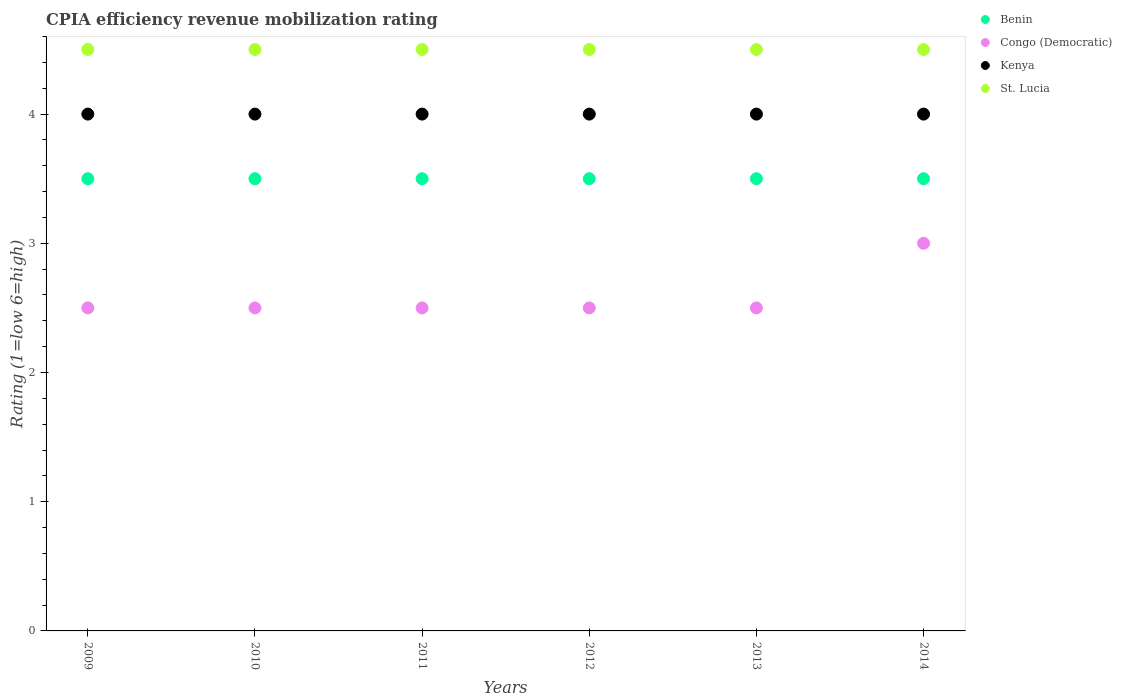Is the number of dotlines equal to the number of legend labels?
Give a very brief answer. Yes. What is the CPIA rating in Kenya in 2012?
Provide a short and direct response. 4. In which year was the CPIA rating in Benin minimum?
Ensure brevity in your answer.  2009. What is the total CPIA rating in Congo (Democratic) in the graph?
Keep it short and to the point. 15.5. What is the difference between the CPIA rating in Kenya in 2009 and the CPIA rating in Benin in 2010?
Offer a very short reply. 0.5. What is the ratio of the CPIA rating in Benin in 2010 to that in 2011?
Provide a succinct answer. 1. Is the CPIA rating in Kenya in 2009 less than that in 2012?
Offer a very short reply. No. What is the difference between the highest and the lowest CPIA rating in St. Lucia?
Provide a succinct answer. 0. Is the CPIA rating in Benin strictly greater than the CPIA rating in Congo (Democratic) over the years?
Keep it short and to the point. Yes. How many dotlines are there?
Keep it short and to the point. 4. How many years are there in the graph?
Offer a terse response. 6. What is the difference between two consecutive major ticks on the Y-axis?
Your answer should be compact. 1. Does the graph contain any zero values?
Your response must be concise. No. Does the graph contain grids?
Provide a short and direct response. No. Where does the legend appear in the graph?
Give a very brief answer. Top right. How many legend labels are there?
Ensure brevity in your answer.  4. What is the title of the graph?
Provide a short and direct response. CPIA efficiency revenue mobilization rating. Does "Tanzania" appear as one of the legend labels in the graph?
Offer a terse response. No. What is the label or title of the X-axis?
Give a very brief answer. Years. What is the Rating (1=low 6=high) in Benin in 2009?
Provide a succinct answer. 3.5. What is the Rating (1=low 6=high) in Congo (Democratic) in 2009?
Make the answer very short. 2.5. What is the Rating (1=low 6=high) of St. Lucia in 2010?
Keep it short and to the point. 4.5. What is the Rating (1=low 6=high) in Benin in 2011?
Provide a short and direct response. 3.5. What is the Rating (1=low 6=high) of St. Lucia in 2011?
Give a very brief answer. 4.5. What is the Rating (1=low 6=high) of Kenya in 2012?
Your response must be concise. 4. What is the Rating (1=low 6=high) in St. Lucia in 2012?
Provide a short and direct response. 4.5. What is the Rating (1=low 6=high) in Congo (Democratic) in 2013?
Keep it short and to the point. 2.5. What is the Rating (1=low 6=high) in Kenya in 2013?
Offer a terse response. 4. What is the Rating (1=low 6=high) in St. Lucia in 2013?
Your answer should be very brief. 4.5. What is the Rating (1=low 6=high) in Congo (Democratic) in 2014?
Provide a short and direct response. 3. What is the Rating (1=low 6=high) in Kenya in 2014?
Give a very brief answer. 4. Across all years, what is the maximum Rating (1=low 6=high) in St. Lucia?
Your answer should be very brief. 4.5. What is the total Rating (1=low 6=high) of Congo (Democratic) in the graph?
Keep it short and to the point. 15.5. What is the total Rating (1=low 6=high) in Kenya in the graph?
Make the answer very short. 24. What is the total Rating (1=low 6=high) in St. Lucia in the graph?
Ensure brevity in your answer.  27. What is the difference between the Rating (1=low 6=high) in Benin in 2009 and that in 2010?
Offer a very short reply. 0. What is the difference between the Rating (1=low 6=high) in Kenya in 2009 and that in 2010?
Keep it short and to the point. 0. What is the difference between the Rating (1=low 6=high) in Benin in 2009 and that in 2011?
Provide a succinct answer. 0. What is the difference between the Rating (1=low 6=high) of Congo (Democratic) in 2009 and that in 2011?
Offer a very short reply. 0. What is the difference between the Rating (1=low 6=high) in Benin in 2009 and that in 2012?
Make the answer very short. 0. What is the difference between the Rating (1=low 6=high) of Kenya in 2009 and that in 2012?
Your response must be concise. 0. What is the difference between the Rating (1=low 6=high) of St. Lucia in 2009 and that in 2012?
Give a very brief answer. 0. What is the difference between the Rating (1=low 6=high) of Kenya in 2009 and that in 2013?
Your answer should be very brief. 0. What is the difference between the Rating (1=low 6=high) of St. Lucia in 2009 and that in 2013?
Ensure brevity in your answer.  0. What is the difference between the Rating (1=low 6=high) in Benin in 2009 and that in 2014?
Give a very brief answer. 0. What is the difference between the Rating (1=low 6=high) in Congo (Democratic) in 2009 and that in 2014?
Provide a short and direct response. -0.5. What is the difference between the Rating (1=low 6=high) in Kenya in 2009 and that in 2014?
Ensure brevity in your answer.  0. What is the difference between the Rating (1=low 6=high) of Benin in 2010 and that in 2011?
Offer a very short reply. 0. What is the difference between the Rating (1=low 6=high) in St. Lucia in 2010 and that in 2011?
Keep it short and to the point. 0. What is the difference between the Rating (1=low 6=high) of Congo (Democratic) in 2010 and that in 2013?
Make the answer very short. 0. What is the difference between the Rating (1=low 6=high) in Congo (Democratic) in 2010 and that in 2014?
Give a very brief answer. -0.5. What is the difference between the Rating (1=low 6=high) of St. Lucia in 2010 and that in 2014?
Your answer should be compact. 0. What is the difference between the Rating (1=low 6=high) of Congo (Democratic) in 2011 and that in 2012?
Provide a short and direct response. 0. What is the difference between the Rating (1=low 6=high) of St. Lucia in 2011 and that in 2012?
Offer a terse response. 0. What is the difference between the Rating (1=low 6=high) of Congo (Democratic) in 2011 and that in 2013?
Provide a short and direct response. 0. What is the difference between the Rating (1=low 6=high) in Congo (Democratic) in 2011 and that in 2014?
Provide a succinct answer. -0.5. What is the difference between the Rating (1=low 6=high) in St. Lucia in 2011 and that in 2014?
Offer a terse response. 0. What is the difference between the Rating (1=low 6=high) in Congo (Democratic) in 2012 and that in 2013?
Ensure brevity in your answer.  0. What is the difference between the Rating (1=low 6=high) of Kenya in 2012 and that in 2013?
Provide a short and direct response. 0. What is the difference between the Rating (1=low 6=high) of St. Lucia in 2012 and that in 2013?
Offer a very short reply. 0. What is the difference between the Rating (1=low 6=high) of Benin in 2012 and that in 2014?
Offer a terse response. 0. What is the difference between the Rating (1=low 6=high) in Congo (Democratic) in 2012 and that in 2014?
Your answer should be compact. -0.5. What is the difference between the Rating (1=low 6=high) in St. Lucia in 2012 and that in 2014?
Provide a succinct answer. 0. What is the difference between the Rating (1=low 6=high) of Benin in 2013 and that in 2014?
Your response must be concise. 0. What is the difference between the Rating (1=low 6=high) of Congo (Democratic) in 2013 and that in 2014?
Keep it short and to the point. -0.5. What is the difference between the Rating (1=low 6=high) in St. Lucia in 2013 and that in 2014?
Offer a terse response. 0. What is the difference between the Rating (1=low 6=high) in Benin in 2009 and the Rating (1=low 6=high) in Congo (Democratic) in 2010?
Keep it short and to the point. 1. What is the difference between the Rating (1=low 6=high) in Congo (Democratic) in 2009 and the Rating (1=low 6=high) in Kenya in 2010?
Offer a very short reply. -1.5. What is the difference between the Rating (1=low 6=high) of Congo (Democratic) in 2009 and the Rating (1=low 6=high) of St. Lucia in 2010?
Give a very brief answer. -2. What is the difference between the Rating (1=low 6=high) in Congo (Democratic) in 2009 and the Rating (1=low 6=high) in Kenya in 2011?
Your answer should be very brief. -1.5. What is the difference between the Rating (1=low 6=high) of Congo (Democratic) in 2009 and the Rating (1=low 6=high) of St. Lucia in 2011?
Offer a very short reply. -2. What is the difference between the Rating (1=low 6=high) in Benin in 2009 and the Rating (1=low 6=high) in Congo (Democratic) in 2012?
Make the answer very short. 1. What is the difference between the Rating (1=low 6=high) in Benin in 2009 and the Rating (1=low 6=high) in St. Lucia in 2012?
Give a very brief answer. -1. What is the difference between the Rating (1=low 6=high) in Kenya in 2009 and the Rating (1=low 6=high) in St. Lucia in 2012?
Your answer should be compact. -0.5. What is the difference between the Rating (1=low 6=high) of Benin in 2009 and the Rating (1=low 6=high) of Congo (Democratic) in 2013?
Your response must be concise. 1. What is the difference between the Rating (1=low 6=high) in Benin in 2009 and the Rating (1=low 6=high) in Kenya in 2013?
Ensure brevity in your answer.  -0.5. What is the difference between the Rating (1=low 6=high) in Congo (Democratic) in 2009 and the Rating (1=low 6=high) in Kenya in 2013?
Keep it short and to the point. -1.5. What is the difference between the Rating (1=low 6=high) in Benin in 2009 and the Rating (1=low 6=high) in St. Lucia in 2014?
Your response must be concise. -1. What is the difference between the Rating (1=low 6=high) in Congo (Democratic) in 2009 and the Rating (1=low 6=high) in Kenya in 2014?
Your answer should be compact. -1.5. What is the difference between the Rating (1=low 6=high) in Congo (Democratic) in 2009 and the Rating (1=low 6=high) in St. Lucia in 2014?
Keep it short and to the point. -2. What is the difference between the Rating (1=low 6=high) in Kenya in 2009 and the Rating (1=low 6=high) in St. Lucia in 2014?
Your response must be concise. -0.5. What is the difference between the Rating (1=low 6=high) in Benin in 2010 and the Rating (1=low 6=high) in Congo (Democratic) in 2011?
Give a very brief answer. 1. What is the difference between the Rating (1=low 6=high) in Benin in 2010 and the Rating (1=low 6=high) in St. Lucia in 2011?
Offer a terse response. -1. What is the difference between the Rating (1=low 6=high) in Congo (Democratic) in 2010 and the Rating (1=low 6=high) in St. Lucia in 2011?
Provide a short and direct response. -2. What is the difference between the Rating (1=low 6=high) in Kenya in 2010 and the Rating (1=low 6=high) in St. Lucia in 2011?
Your answer should be very brief. -0.5. What is the difference between the Rating (1=low 6=high) of Benin in 2010 and the Rating (1=low 6=high) of Congo (Democratic) in 2012?
Provide a succinct answer. 1. What is the difference between the Rating (1=low 6=high) of Benin in 2010 and the Rating (1=low 6=high) of Kenya in 2012?
Your answer should be compact. -0.5. What is the difference between the Rating (1=low 6=high) in Congo (Democratic) in 2010 and the Rating (1=low 6=high) in Kenya in 2012?
Make the answer very short. -1.5. What is the difference between the Rating (1=low 6=high) in Benin in 2010 and the Rating (1=low 6=high) in St. Lucia in 2013?
Keep it short and to the point. -1. What is the difference between the Rating (1=low 6=high) of Congo (Democratic) in 2010 and the Rating (1=low 6=high) of Kenya in 2013?
Your answer should be very brief. -1.5. What is the difference between the Rating (1=low 6=high) in Congo (Democratic) in 2010 and the Rating (1=low 6=high) in St. Lucia in 2013?
Offer a very short reply. -2. What is the difference between the Rating (1=low 6=high) of Benin in 2010 and the Rating (1=low 6=high) of Congo (Democratic) in 2014?
Offer a terse response. 0.5. What is the difference between the Rating (1=low 6=high) in Congo (Democratic) in 2010 and the Rating (1=low 6=high) in Kenya in 2014?
Give a very brief answer. -1.5. What is the difference between the Rating (1=low 6=high) in Congo (Democratic) in 2010 and the Rating (1=low 6=high) in St. Lucia in 2014?
Your answer should be very brief. -2. What is the difference between the Rating (1=low 6=high) in Benin in 2011 and the Rating (1=low 6=high) in St. Lucia in 2012?
Your response must be concise. -1. What is the difference between the Rating (1=low 6=high) in Kenya in 2011 and the Rating (1=low 6=high) in St. Lucia in 2012?
Offer a terse response. -0.5. What is the difference between the Rating (1=low 6=high) in Congo (Democratic) in 2011 and the Rating (1=low 6=high) in Kenya in 2013?
Keep it short and to the point. -1.5. What is the difference between the Rating (1=low 6=high) in Benin in 2011 and the Rating (1=low 6=high) in Congo (Democratic) in 2014?
Your response must be concise. 0.5. What is the difference between the Rating (1=low 6=high) in Benin in 2011 and the Rating (1=low 6=high) in St. Lucia in 2014?
Make the answer very short. -1. What is the difference between the Rating (1=low 6=high) of Congo (Democratic) in 2011 and the Rating (1=low 6=high) of Kenya in 2014?
Your answer should be compact. -1.5. What is the difference between the Rating (1=low 6=high) of Benin in 2012 and the Rating (1=low 6=high) of Kenya in 2013?
Provide a short and direct response. -0.5. What is the difference between the Rating (1=low 6=high) in Benin in 2012 and the Rating (1=low 6=high) in St. Lucia in 2013?
Keep it short and to the point. -1. What is the difference between the Rating (1=low 6=high) in Congo (Democratic) in 2012 and the Rating (1=low 6=high) in St. Lucia in 2013?
Provide a short and direct response. -2. What is the difference between the Rating (1=low 6=high) of Kenya in 2012 and the Rating (1=low 6=high) of St. Lucia in 2013?
Your response must be concise. -0.5. What is the difference between the Rating (1=low 6=high) of Benin in 2012 and the Rating (1=low 6=high) of Congo (Democratic) in 2014?
Provide a short and direct response. 0.5. What is the difference between the Rating (1=low 6=high) of Benin in 2012 and the Rating (1=low 6=high) of Kenya in 2014?
Make the answer very short. -0.5. What is the difference between the Rating (1=low 6=high) in Benin in 2012 and the Rating (1=low 6=high) in St. Lucia in 2014?
Offer a terse response. -1. What is the difference between the Rating (1=low 6=high) of Congo (Democratic) in 2012 and the Rating (1=low 6=high) of Kenya in 2014?
Provide a short and direct response. -1.5. What is the difference between the Rating (1=low 6=high) in Benin in 2013 and the Rating (1=low 6=high) in Kenya in 2014?
Keep it short and to the point. -0.5. What is the difference between the Rating (1=low 6=high) of Congo (Democratic) in 2013 and the Rating (1=low 6=high) of Kenya in 2014?
Offer a very short reply. -1.5. What is the difference between the Rating (1=low 6=high) in Congo (Democratic) in 2013 and the Rating (1=low 6=high) in St. Lucia in 2014?
Ensure brevity in your answer.  -2. What is the average Rating (1=low 6=high) of Benin per year?
Your answer should be compact. 3.5. What is the average Rating (1=low 6=high) in Congo (Democratic) per year?
Give a very brief answer. 2.58. In the year 2009, what is the difference between the Rating (1=low 6=high) in Benin and Rating (1=low 6=high) in St. Lucia?
Provide a succinct answer. -1. In the year 2009, what is the difference between the Rating (1=low 6=high) of Congo (Democratic) and Rating (1=low 6=high) of St. Lucia?
Offer a very short reply. -2. In the year 2009, what is the difference between the Rating (1=low 6=high) of Kenya and Rating (1=low 6=high) of St. Lucia?
Keep it short and to the point. -0.5. In the year 2010, what is the difference between the Rating (1=low 6=high) in Benin and Rating (1=low 6=high) in Kenya?
Offer a terse response. -0.5. In the year 2010, what is the difference between the Rating (1=low 6=high) of Benin and Rating (1=low 6=high) of St. Lucia?
Make the answer very short. -1. In the year 2011, what is the difference between the Rating (1=low 6=high) of Benin and Rating (1=low 6=high) of Congo (Democratic)?
Provide a succinct answer. 1. In the year 2011, what is the difference between the Rating (1=low 6=high) of Kenya and Rating (1=low 6=high) of St. Lucia?
Your answer should be very brief. -0.5. In the year 2012, what is the difference between the Rating (1=low 6=high) in Benin and Rating (1=low 6=high) in St. Lucia?
Provide a succinct answer. -1. In the year 2012, what is the difference between the Rating (1=low 6=high) of Congo (Democratic) and Rating (1=low 6=high) of Kenya?
Provide a succinct answer. -1.5. In the year 2012, what is the difference between the Rating (1=low 6=high) of Kenya and Rating (1=low 6=high) of St. Lucia?
Ensure brevity in your answer.  -0.5. In the year 2014, what is the difference between the Rating (1=low 6=high) in Benin and Rating (1=low 6=high) in Congo (Democratic)?
Your response must be concise. 0.5. In the year 2014, what is the difference between the Rating (1=low 6=high) in Benin and Rating (1=low 6=high) in Kenya?
Give a very brief answer. -0.5. In the year 2014, what is the difference between the Rating (1=low 6=high) in Congo (Democratic) and Rating (1=low 6=high) in Kenya?
Provide a short and direct response. -1. In the year 2014, what is the difference between the Rating (1=low 6=high) of Kenya and Rating (1=low 6=high) of St. Lucia?
Make the answer very short. -0.5. What is the ratio of the Rating (1=low 6=high) of Benin in 2009 to that in 2010?
Your response must be concise. 1. What is the ratio of the Rating (1=low 6=high) in Benin in 2009 to that in 2011?
Provide a succinct answer. 1. What is the ratio of the Rating (1=low 6=high) of Kenya in 2009 to that in 2011?
Your answer should be very brief. 1. What is the ratio of the Rating (1=low 6=high) in Benin in 2009 to that in 2012?
Provide a short and direct response. 1. What is the ratio of the Rating (1=low 6=high) in Congo (Democratic) in 2009 to that in 2012?
Provide a short and direct response. 1. What is the ratio of the Rating (1=low 6=high) in Benin in 2009 to that in 2013?
Provide a short and direct response. 1. What is the ratio of the Rating (1=low 6=high) in Congo (Democratic) in 2009 to that in 2013?
Give a very brief answer. 1. What is the ratio of the Rating (1=low 6=high) of Congo (Democratic) in 2009 to that in 2014?
Ensure brevity in your answer.  0.83. What is the ratio of the Rating (1=low 6=high) in Kenya in 2009 to that in 2014?
Provide a succinct answer. 1. What is the ratio of the Rating (1=low 6=high) of St. Lucia in 2009 to that in 2014?
Provide a succinct answer. 1. What is the ratio of the Rating (1=low 6=high) in Kenya in 2010 to that in 2011?
Your response must be concise. 1. What is the ratio of the Rating (1=low 6=high) of St. Lucia in 2010 to that in 2011?
Ensure brevity in your answer.  1. What is the ratio of the Rating (1=low 6=high) of Kenya in 2010 to that in 2012?
Give a very brief answer. 1. What is the ratio of the Rating (1=low 6=high) in St. Lucia in 2010 to that in 2012?
Offer a terse response. 1. What is the ratio of the Rating (1=low 6=high) in Kenya in 2010 to that in 2013?
Ensure brevity in your answer.  1. What is the ratio of the Rating (1=low 6=high) in Kenya in 2010 to that in 2014?
Make the answer very short. 1. What is the ratio of the Rating (1=low 6=high) of St. Lucia in 2010 to that in 2014?
Provide a succinct answer. 1. What is the ratio of the Rating (1=low 6=high) of Congo (Democratic) in 2011 to that in 2012?
Offer a very short reply. 1. What is the ratio of the Rating (1=low 6=high) of St. Lucia in 2011 to that in 2012?
Provide a short and direct response. 1. What is the ratio of the Rating (1=low 6=high) in Congo (Democratic) in 2011 to that in 2013?
Your answer should be compact. 1. What is the ratio of the Rating (1=low 6=high) in Congo (Democratic) in 2011 to that in 2014?
Offer a terse response. 0.83. What is the ratio of the Rating (1=low 6=high) in St. Lucia in 2011 to that in 2014?
Offer a terse response. 1. What is the ratio of the Rating (1=low 6=high) in Kenya in 2012 to that in 2013?
Provide a short and direct response. 1. What is the ratio of the Rating (1=low 6=high) of St. Lucia in 2012 to that in 2013?
Offer a very short reply. 1. What is the ratio of the Rating (1=low 6=high) of Congo (Democratic) in 2013 to that in 2014?
Give a very brief answer. 0.83. What is the ratio of the Rating (1=low 6=high) of Kenya in 2013 to that in 2014?
Provide a succinct answer. 1. What is the difference between the highest and the second highest Rating (1=low 6=high) in Benin?
Provide a succinct answer. 0. What is the difference between the highest and the second highest Rating (1=low 6=high) of Kenya?
Offer a terse response. 0. What is the difference between the highest and the lowest Rating (1=low 6=high) in Congo (Democratic)?
Give a very brief answer. 0.5. What is the difference between the highest and the lowest Rating (1=low 6=high) in St. Lucia?
Offer a terse response. 0. 